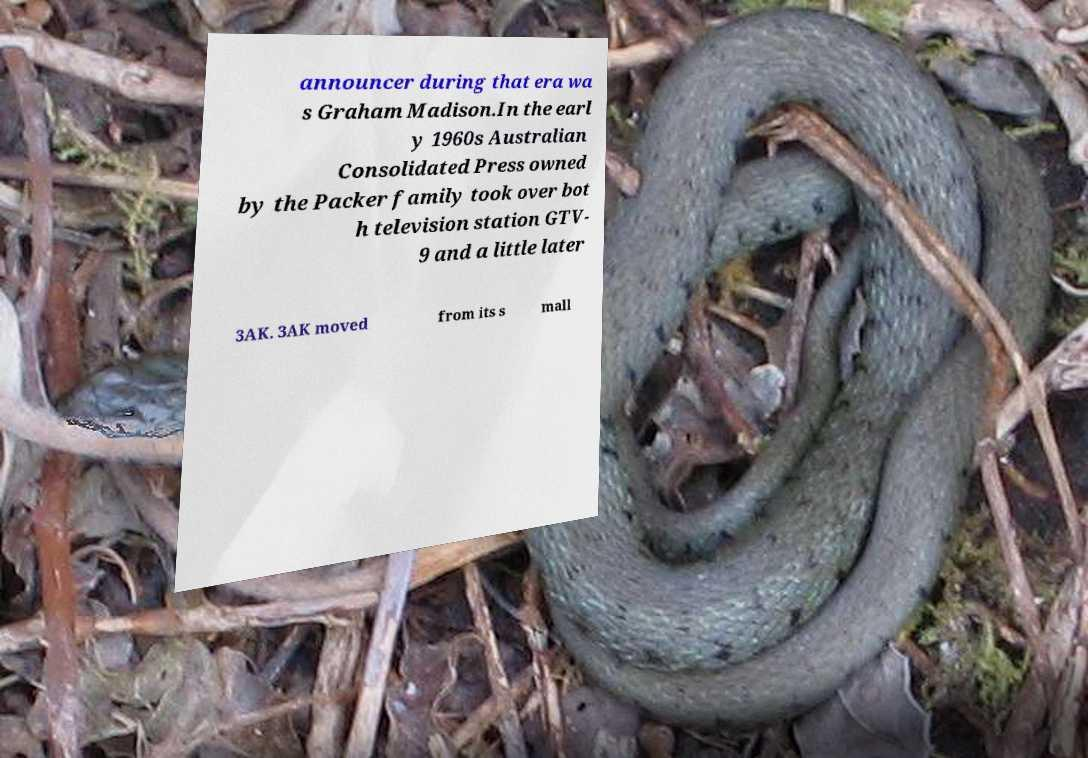For documentation purposes, I need the text within this image transcribed. Could you provide that? announcer during that era wa s Graham Madison.In the earl y 1960s Australian Consolidated Press owned by the Packer family took over bot h television station GTV- 9 and a little later 3AK. 3AK moved from its s mall 